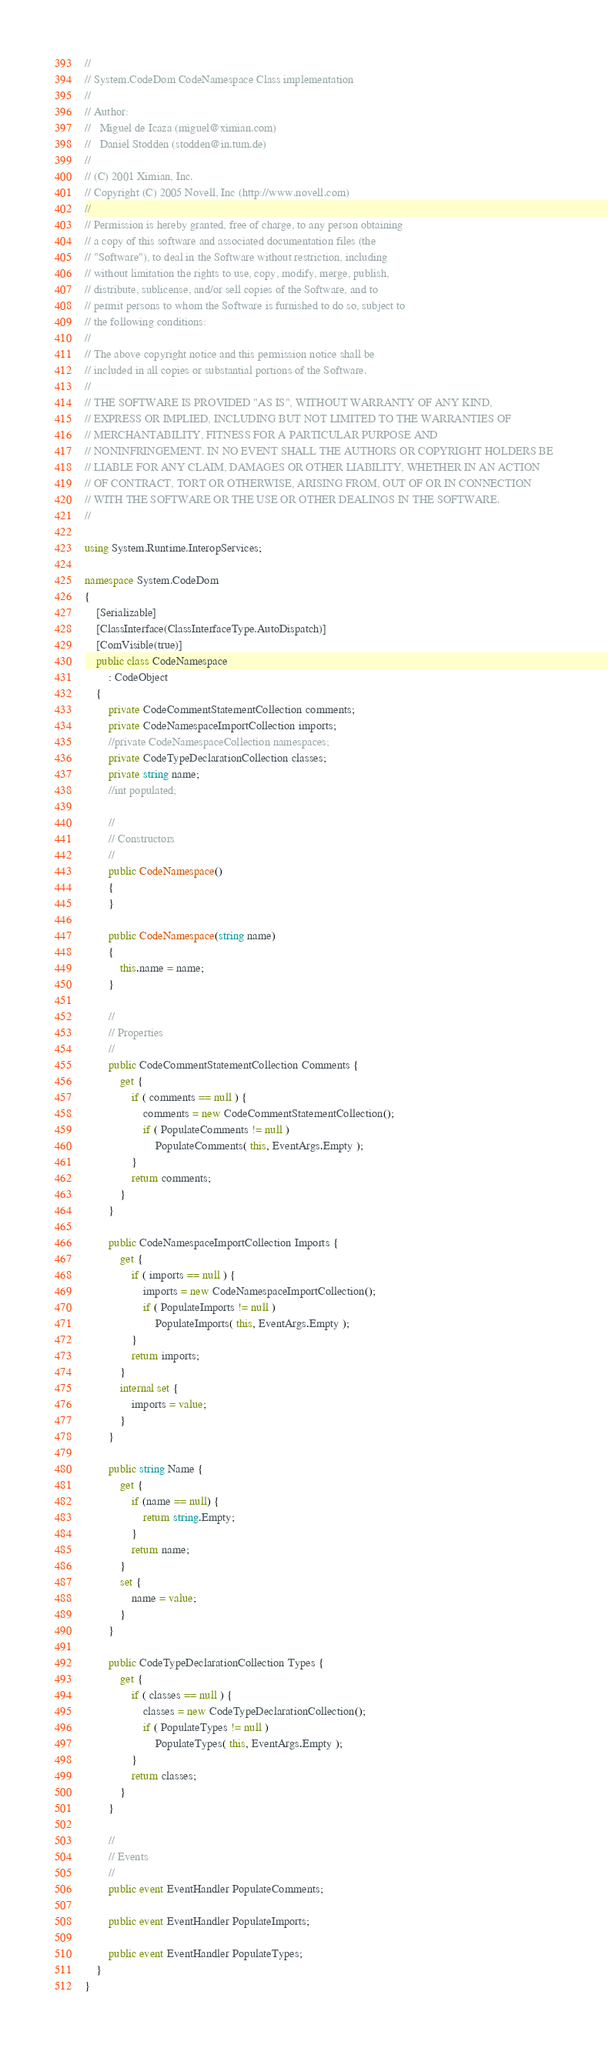<code> <loc_0><loc_0><loc_500><loc_500><_C#_>//
// System.CodeDom CodeNamespace Class implementation
//
// Author:
//   Miguel de Icaza (miguel@ximian.com)
//   Daniel Stodden (stodden@in.tum.de)
//
// (C) 2001 Ximian, Inc.
// Copyright (C) 2005 Novell, Inc (http://www.novell.com)
//
// Permission is hereby granted, free of charge, to any person obtaining
// a copy of this software and associated documentation files (the
// "Software"), to deal in the Software without restriction, including
// without limitation the rights to use, copy, modify, merge, publish,
// distribute, sublicense, and/or sell copies of the Software, and to
// permit persons to whom the Software is furnished to do so, subject to
// the following conditions:
// 
// The above copyright notice and this permission notice shall be
// included in all copies or substantial portions of the Software.
// 
// THE SOFTWARE IS PROVIDED "AS IS", WITHOUT WARRANTY OF ANY KIND,
// EXPRESS OR IMPLIED, INCLUDING BUT NOT LIMITED TO THE WARRANTIES OF
// MERCHANTABILITY, FITNESS FOR A PARTICULAR PURPOSE AND
// NONINFRINGEMENT. IN NO EVENT SHALL THE AUTHORS OR COPYRIGHT HOLDERS BE
// LIABLE FOR ANY CLAIM, DAMAGES OR OTHER LIABILITY, WHETHER IN AN ACTION
// OF CONTRACT, TORT OR OTHERWISE, ARISING FROM, OUT OF OR IN CONNECTION
// WITH THE SOFTWARE OR THE USE OR OTHER DEALINGS IN THE SOFTWARE.
//

using System.Runtime.InteropServices;

namespace System.CodeDom
{
	[Serializable]
	[ClassInterface(ClassInterfaceType.AutoDispatch)]
	[ComVisible(true)]
	public class CodeNamespace
		: CodeObject
	{
		private CodeCommentStatementCollection comments;
		private CodeNamespaceImportCollection imports;
		//private CodeNamespaceCollection namespaces;
		private CodeTypeDeclarationCollection classes;
		private string name;
		//int populated;

		//
		// Constructors
		//
		public CodeNamespace()
		{
		}

		public CodeNamespace(string name)
		{
			this.name = name;
		}

		//
		// Properties
		//
		public CodeCommentStatementCollection Comments {
			get {
				if ( comments == null ) {
					comments = new CodeCommentStatementCollection();
					if ( PopulateComments != null )
						PopulateComments( this, EventArgs.Empty );
				}
				return comments;
			}
		}

		public CodeNamespaceImportCollection Imports {
			get {
				if ( imports == null ) {
					imports = new CodeNamespaceImportCollection();
					if ( PopulateImports != null )
						PopulateImports( this, EventArgs.Empty );
				}
				return imports;
			}
			internal set {
				imports = value;
			}
		}

		public string Name {
			get {
				if (name == null) {
					return string.Empty;
				}
				return name;
			}
			set {
				name = value;
			}
		}

		public CodeTypeDeclarationCollection Types {
			get {
				if ( classes == null ) {
					classes = new CodeTypeDeclarationCollection();
					if ( PopulateTypes != null )
						PopulateTypes( this, EventArgs.Empty );
				}
				return classes;
			}
		}

		//
		// Events
		//
		public event EventHandler PopulateComments;
		
		public event EventHandler PopulateImports;
		
		public event EventHandler PopulateTypes;
	}
}
</code> 